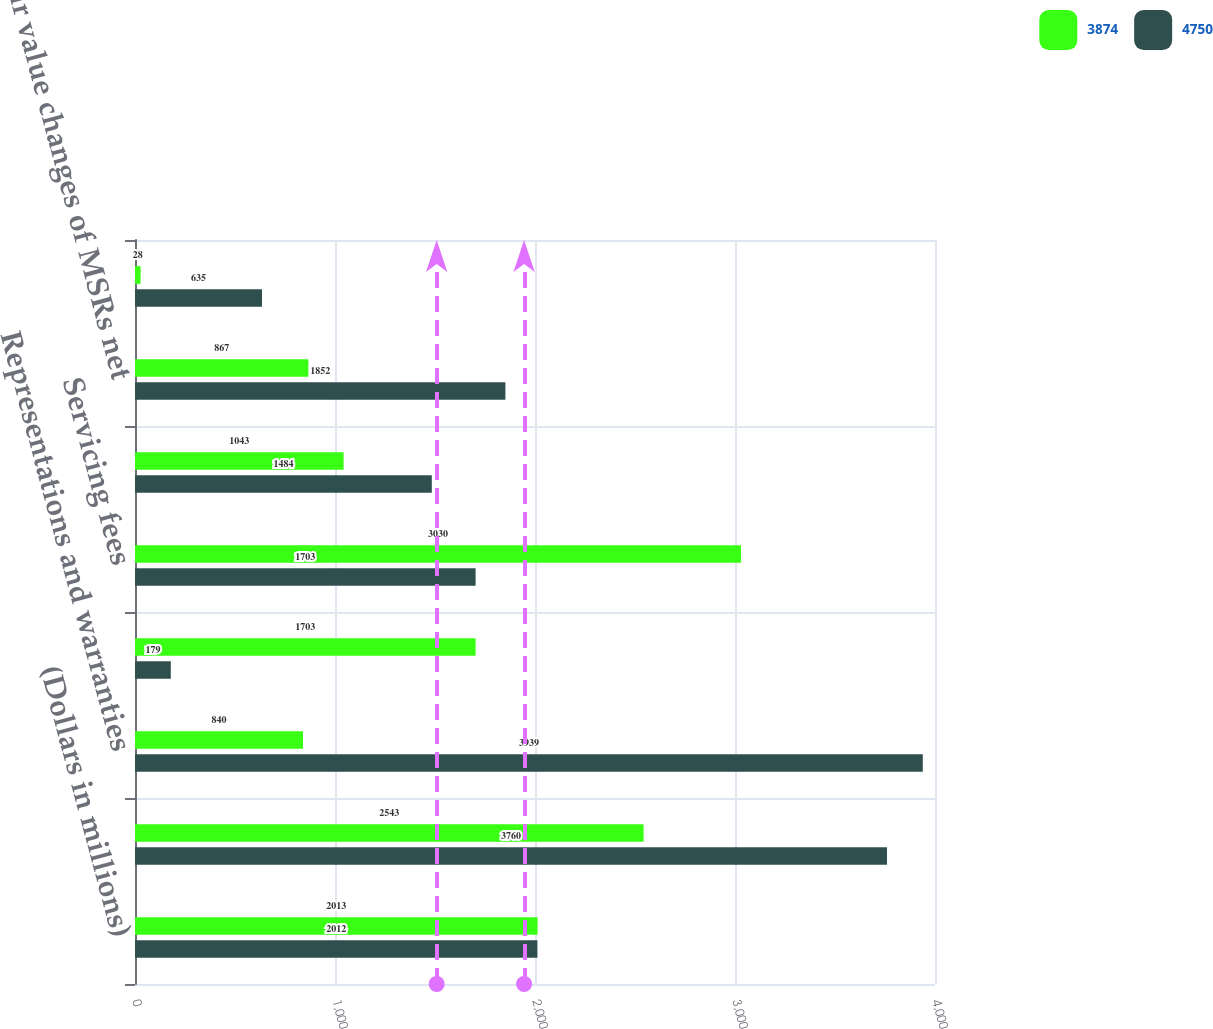Convert chart. <chart><loc_0><loc_0><loc_500><loc_500><stacked_bar_chart><ecel><fcel>(Dollars in millions)<fcel>Core production revenue<fcel>Representations and warranties<fcel>Total production income (loss)<fcel>Servicing fees<fcel>Amortization of expected cash<fcel>Fair value changes of MSRs net<fcel>Other servicing-related<nl><fcel>3874<fcel>2013<fcel>2543<fcel>840<fcel>1703<fcel>3030<fcel>1043<fcel>867<fcel>28<nl><fcel>4750<fcel>2012<fcel>3760<fcel>3939<fcel>179<fcel>1703<fcel>1484<fcel>1852<fcel>635<nl></chart> 